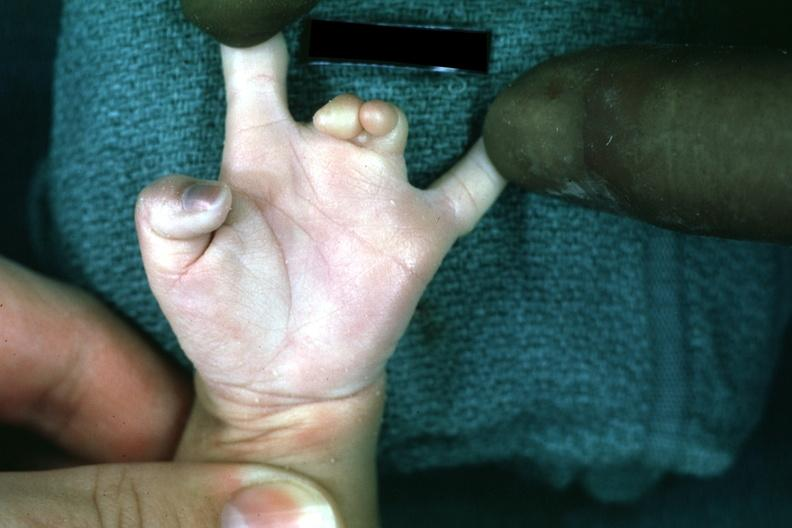re intraductal lesions present?
Answer the question using a single word or phrase. No 